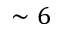Convert formula to latex. <formula><loc_0><loc_0><loc_500><loc_500>\sim 6</formula> 